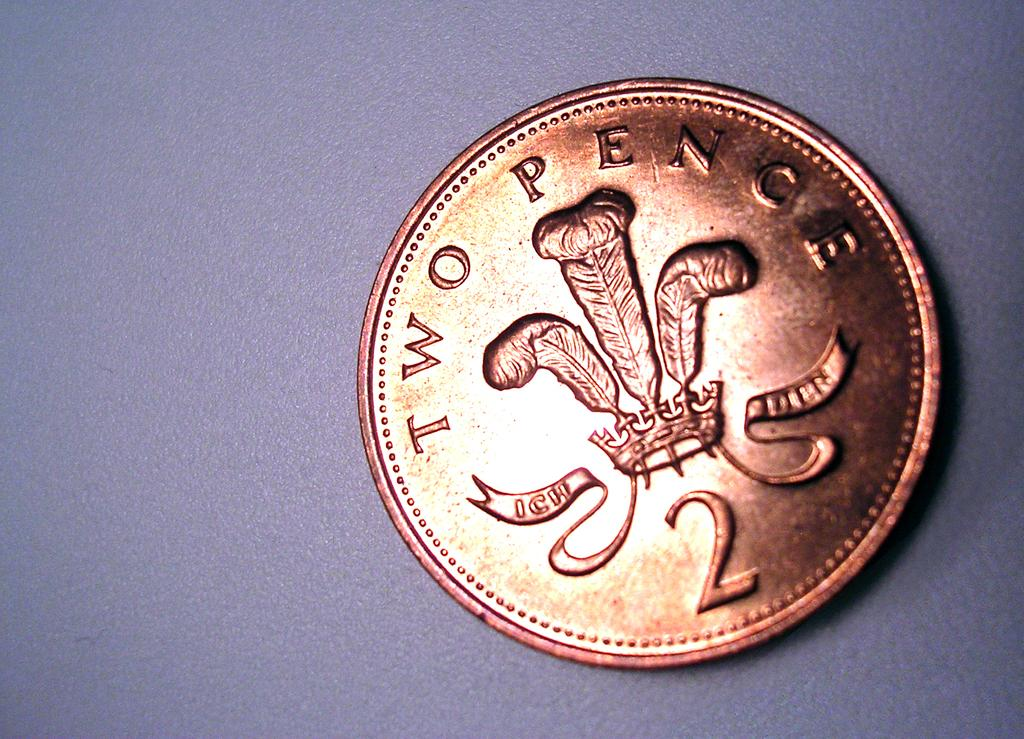<image>
Render a clear and concise summary of the photo. A two pence coin is on a blue colored background. 